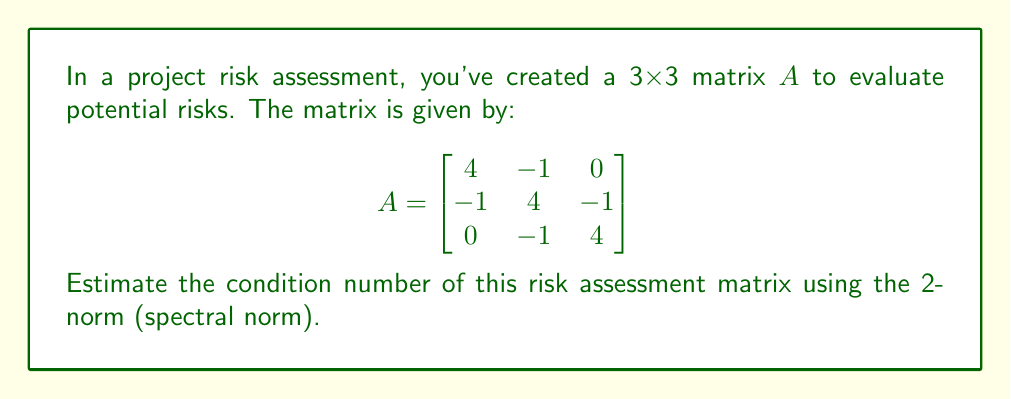Can you answer this question? To estimate the condition number of matrix A using the 2-norm, we need to follow these steps:

1. The condition number is defined as:
   $$\kappa(A) = \|A\| \cdot \|A^{-1}\|$$
   where $\|\cdot\|$ denotes the 2-norm (spectral norm).

2. For a symmetric matrix, the 2-norm is equal to the largest absolute eigenvalue.

3. To find the eigenvalues, we solve the characteristic equation:
   $$\det(A - \lambda I) = 0$$

4. Expanding the determinant:
   $$(4-\lambda)((4-\lambda)(4-\lambda) - 1) - (-1)(-1(4-\lambda) - 0) = 0$$
   $$(4-\lambda)((4-\lambda)^2 - 1) + (4-\lambda) = 0$$
   $$(4-\lambda)((4-\lambda)^2 - 1 + 1) = 0$$
   $$(4-\lambda)((4-\lambda)^2) = 0$$

5. Solving this equation:
   $\lambda_1 = 4$
   $\lambda_2 = 4 - \sqrt{2}$
   $\lambda_3 = 4 + \sqrt{2}$

6. The largest absolute eigenvalue is $4 + \sqrt{2}$, so:
   $$\|A\| = 4 + \sqrt{2}$$

7. For the inverse matrix, the eigenvalues are the reciprocals of A's eigenvalues:
   $\frac{1}{4}$, $\frac{1}{4-\sqrt{2}}$, $\frac{1}{4+\sqrt{2}}$

8. The largest absolute eigenvalue of $A^{-1}$ is $\frac{1}{4-\sqrt{2}}$, so:
   $$\|A^{-1}\| = \frac{1}{4-\sqrt{2}}$$

9. Therefore, the condition number is:
   $$\kappa(A) = \|A\| \cdot \|A^{-1}\| = (4 + \sqrt{2}) \cdot \frac{1}{4-\sqrt{2}}$$

10. Simplifying:
    $$\kappa(A) = \frac{(4 + \sqrt{2})(4+\sqrt{2})}{(4-\sqrt{2})(4+\sqrt{2})} = \frac{4 + \sqrt{2}}{4-\sqrt{2}} \approx 3.73$$
Answer: $\frac{4 + \sqrt{2}}{4-\sqrt{2}} \approx 3.73$ 